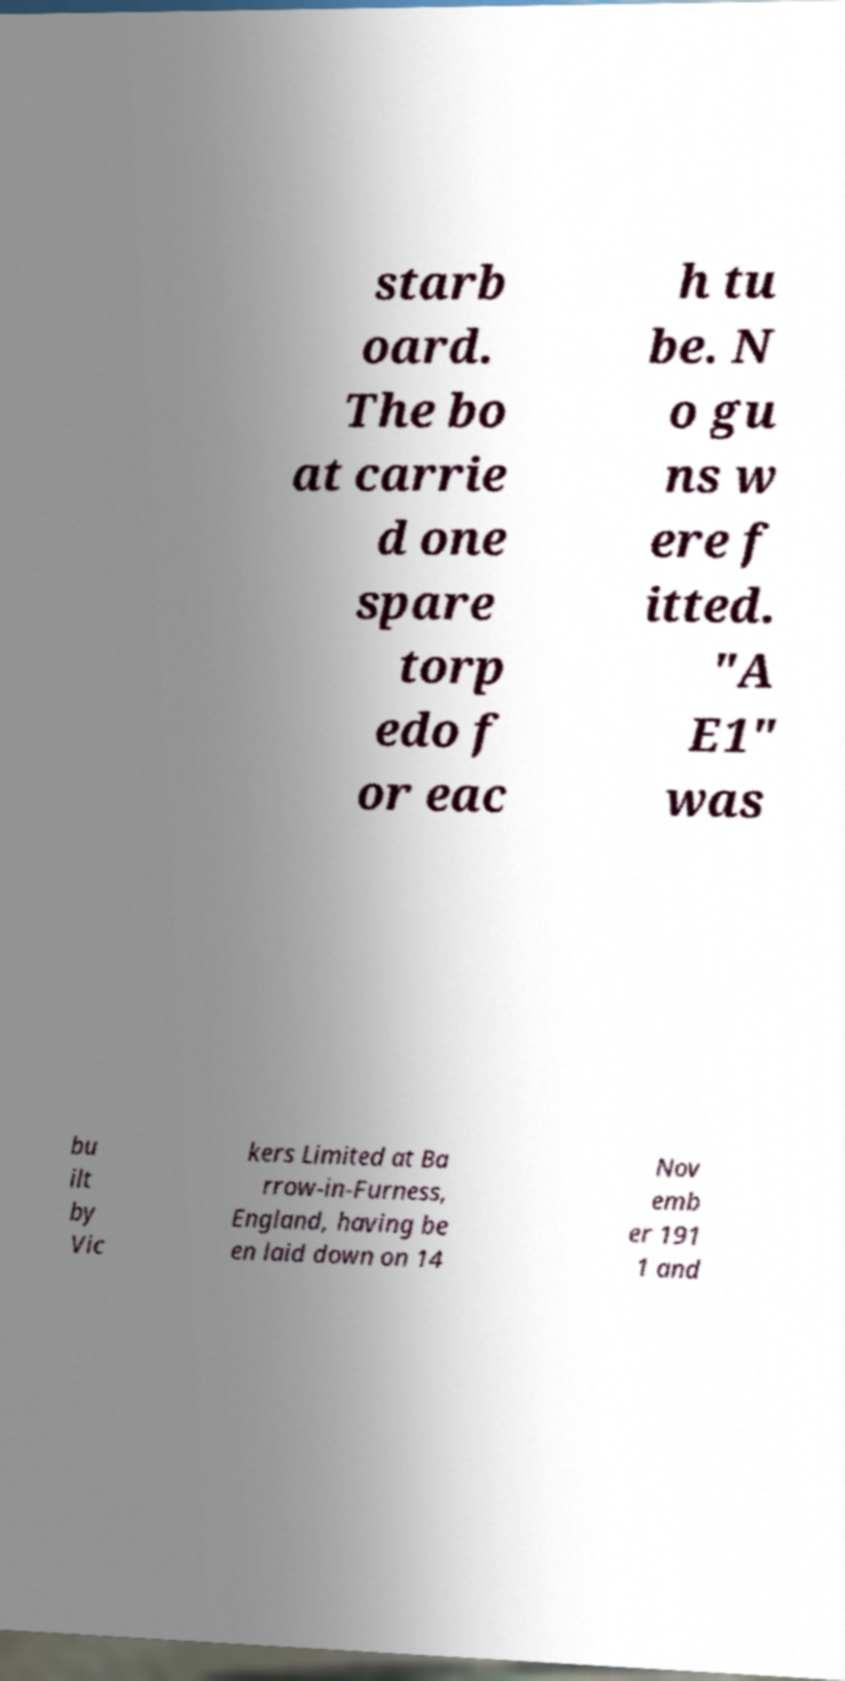There's text embedded in this image that I need extracted. Can you transcribe it verbatim? starb oard. The bo at carrie d one spare torp edo f or eac h tu be. N o gu ns w ere f itted. "A E1" was bu ilt by Vic kers Limited at Ba rrow-in-Furness, England, having be en laid down on 14 Nov emb er 191 1 and 